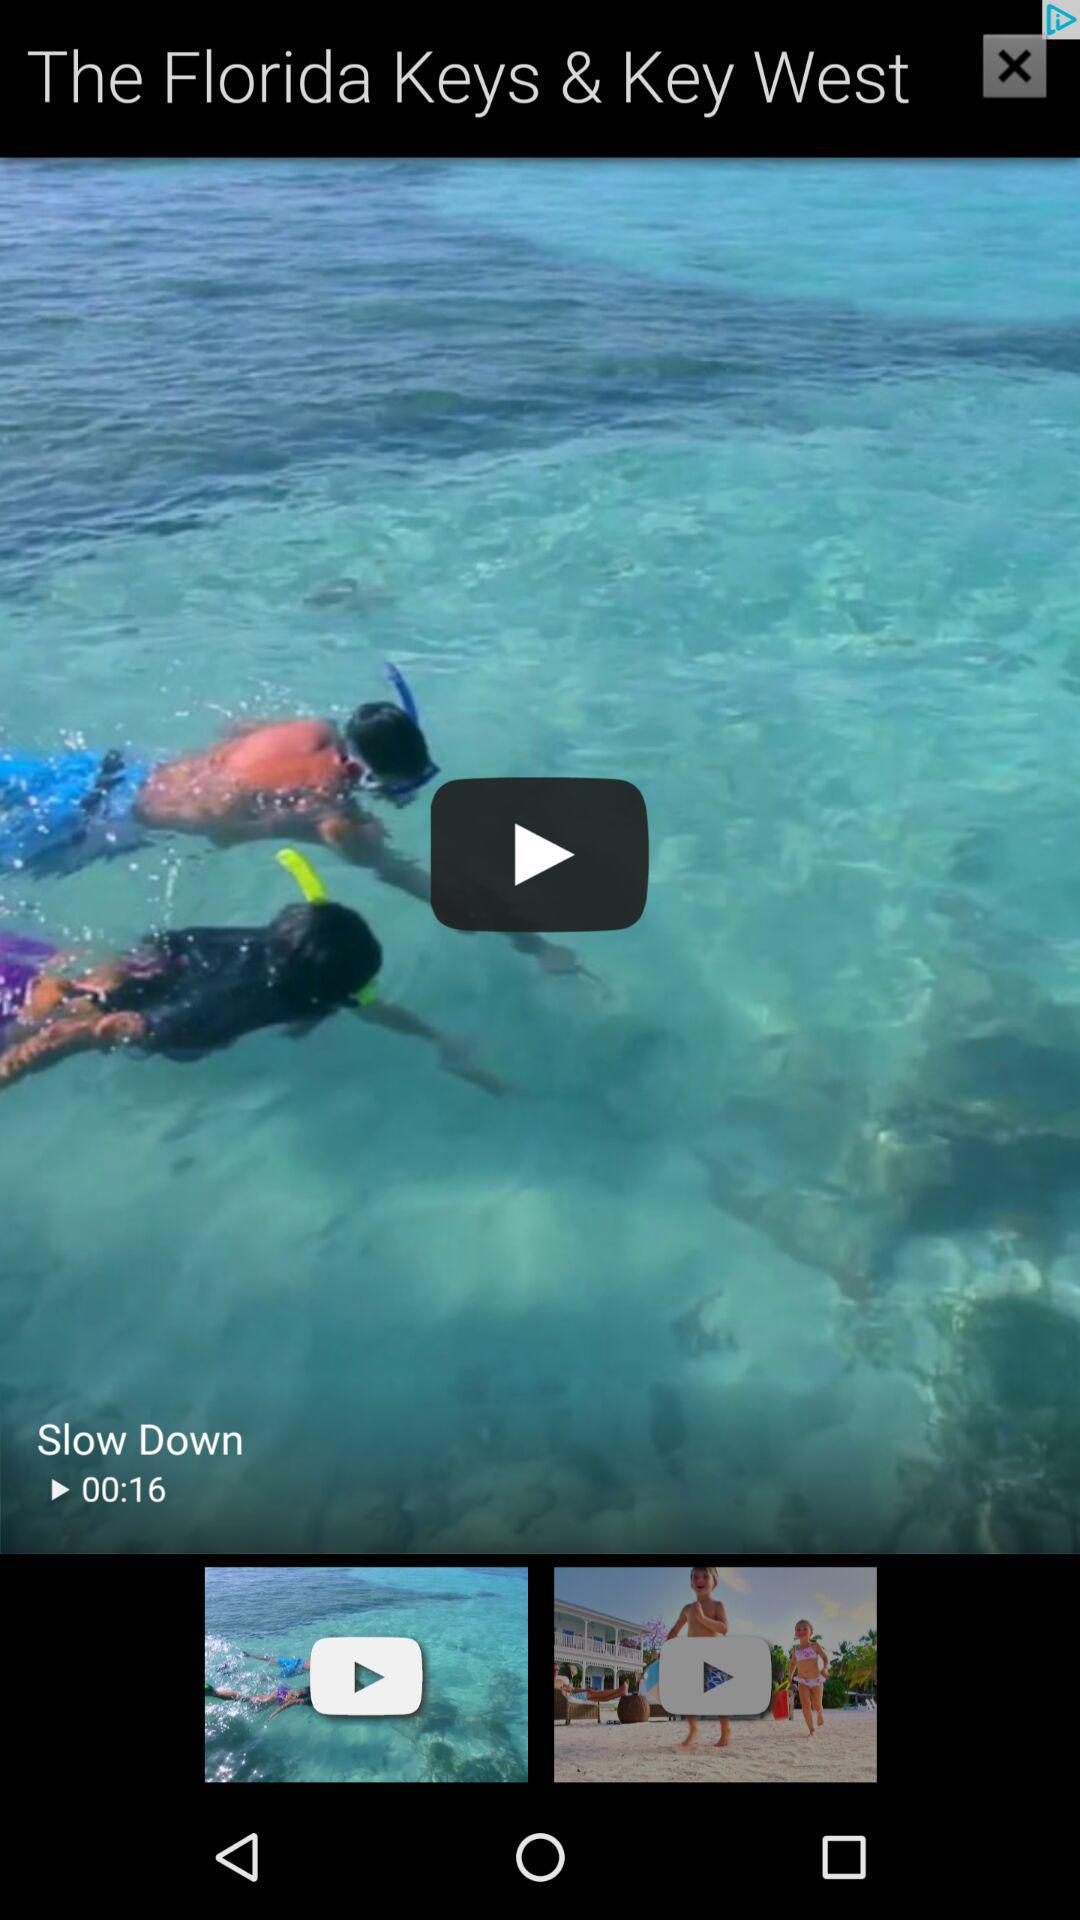What is the length of the video "Slow Down"? The length of the video is 16 seconds. 